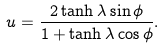Convert formula to latex. <formula><loc_0><loc_0><loc_500><loc_500>u = \frac { 2 \tanh \lambda \sin \phi } { 1 + \tanh \lambda \cos \phi } .</formula> 